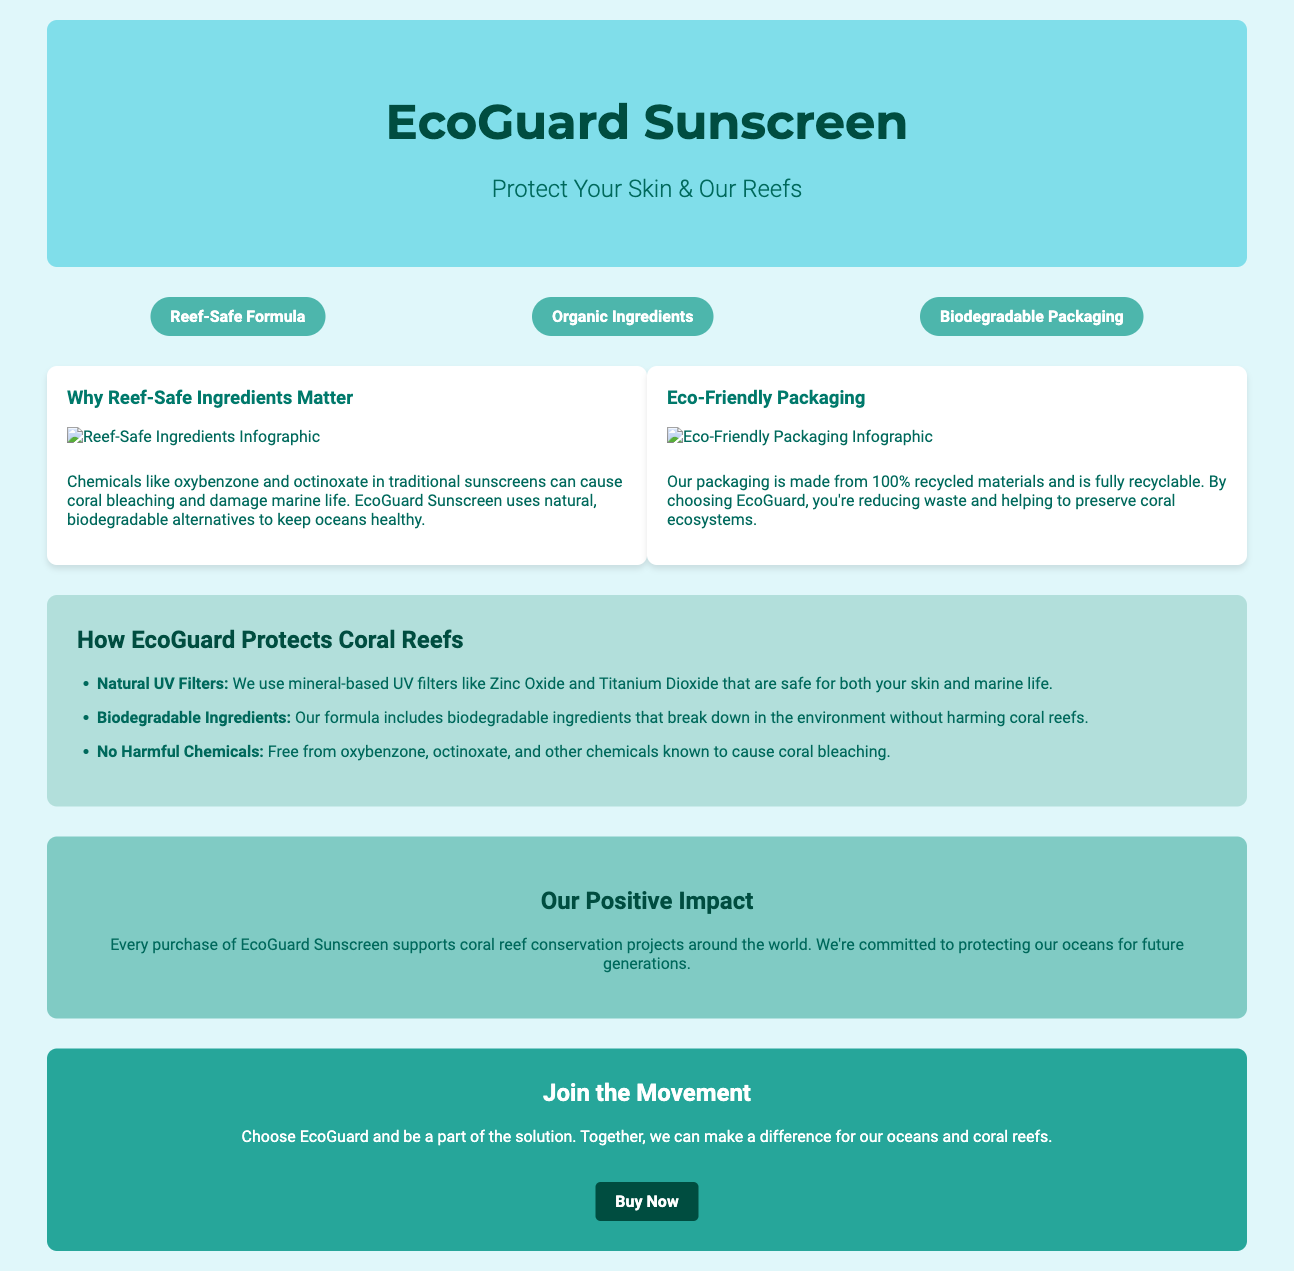what is the product name? The product name is mentioned in the header of the document.
Answer: EcoGuard Sunscreen what is the tagline of the product? The tagline appears under the product name in the header section.
Answer: Protect Your Skin & Our Reefs how many key features are listed? The document lists features in a three-column layout under 'key features'.
Answer: Three which harmful chemicals are excluded from the formula? The document specifically identifies harmful chemicals known to cause coral bleaching in the 'how it works' section.
Answer: Oxybenzone, Octinoxate what type of packaging is used for EcoGuard? The packaging information is included in the infographic section of the document.
Answer: Biodegradable Packaging what is the main focus of EcoGuard Sunscreen? The primary objective is outlined in the opening sections and infographics.
Answer: Coral reef protection how does EcoGuard support conservation efforts? The impact section highlights the brand's commitment to conservation projects through purchases.
Answer: Supports coral reef conservation projects who can benefit from using EcoGuard Sunscreen? The audience targeted can be inferred from the document's focus on coral protection.
Answer: People who care about coral reefs what action is encouraged at the end of the document? The call-to-action section promotes a specific response from readers.
Answer: Buy Now 